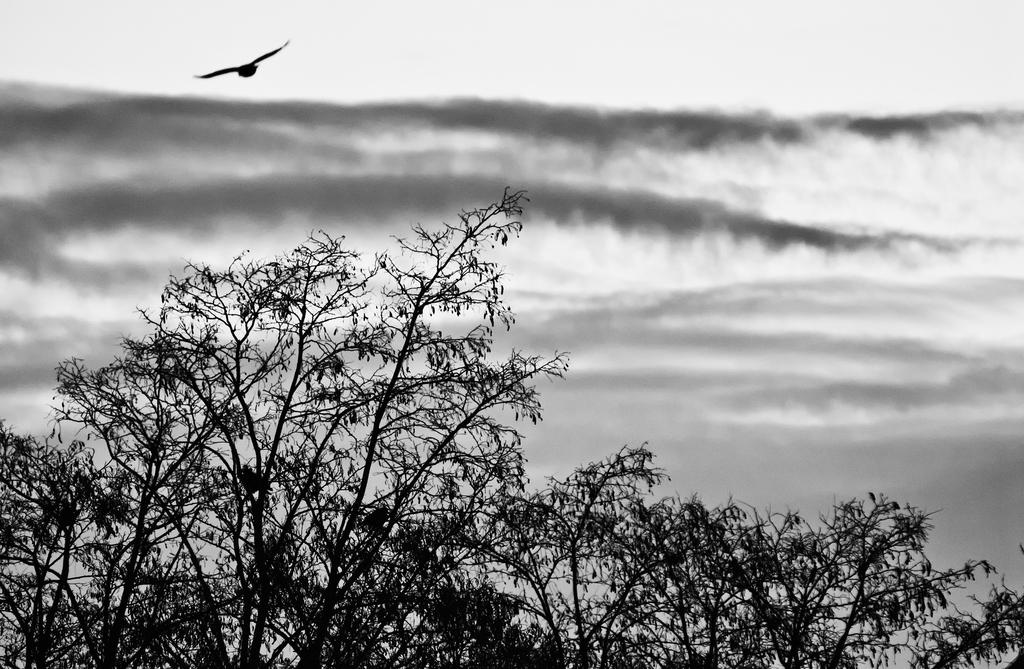What is the color scheme of the image? The image is black and white. What type of natural elements can be seen in the image? There is a picture of trees and a picture of water in the image. What is happening in the sky in the image? There is a bird flying in the sky in the image. What type of birth is depicted in the image? There is no birth depicted in the image; it features pictures of trees, water, and a bird flying in the sky. What class is being taught in the image? There is no class or teaching activity depicted in the image. 